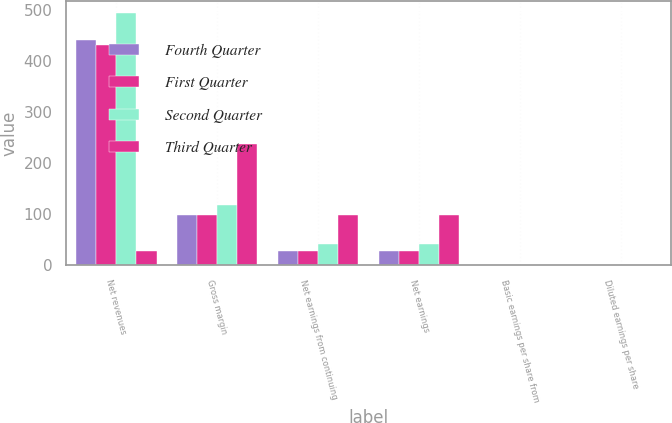Convert chart to OTSL. <chart><loc_0><loc_0><loc_500><loc_500><stacked_bar_chart><ecel><fcel>Net revenues<fcel>Gross margin<fcel>Net earnings from continuing<fcel>Net earnings<fcel>Basic earnings per share from<fcel>Diluted earnings per share<nl><fcel>Fourth Quarter<fcel>440.1<fcel>97.5<fcel>28.5<fcel>28.5<fcel>0.21<fcel>0.21<nl><fcel>First Quarter<fcel>431.3<fcel>98.1<fcel>28<fcel>28<fcel>0.2<fcel>0.2<nl><fcel>Second Quarter<fcel>492.8<fcel>117.7<fcel>41.9<fcel>41.9<fcel>0.3<fcel>0.3<nl><fcel>Third Quarter<fcel>28.5<fcel>236.5<fcel>98.7<fcel>98.7<fcel>0.71<fcel>0.71<nl></chart> 